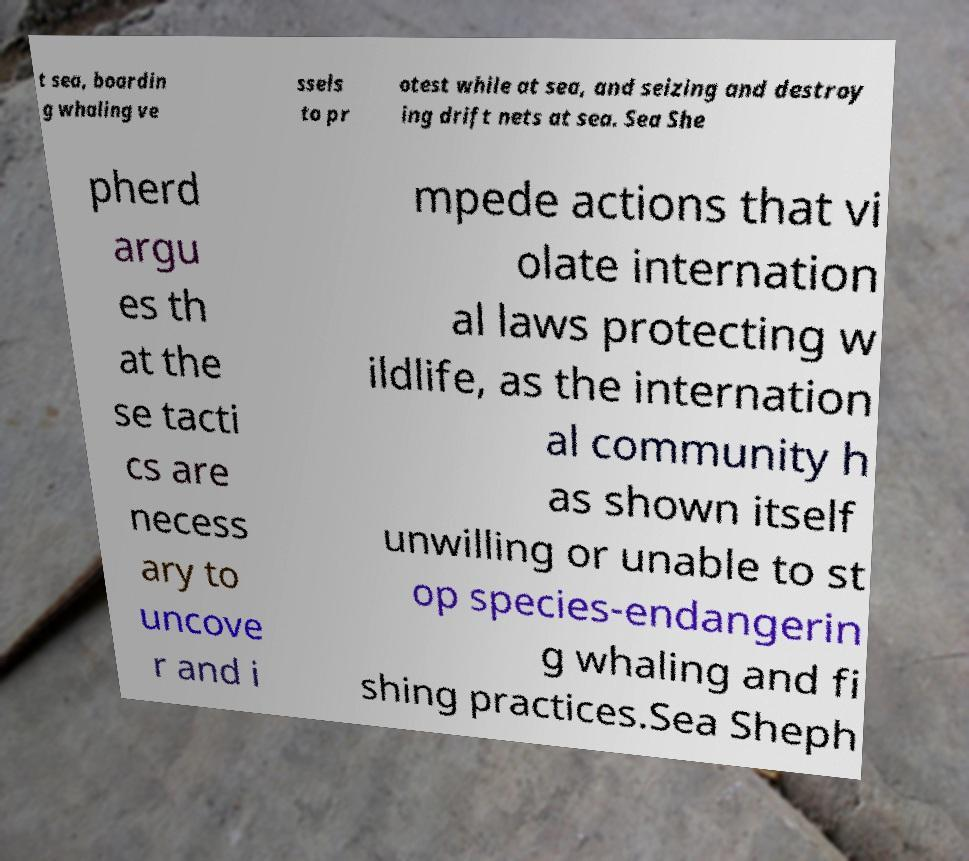Please read and relay the text visible in this image. What does it say? t sea, boardin g whaling ve ssels to pr otest while at sea, and seizing and destroy ing drift nets at sea. Sea She pherd argu es th at the se tacti cs are necess ary to uncove r and i mpede actions that vi olate internation al laws protecting w ildlife, as the internation al community h as shown itself unwilling or unable to st op species-endangerin g whaling and fi shing practices.Sea Sheph 